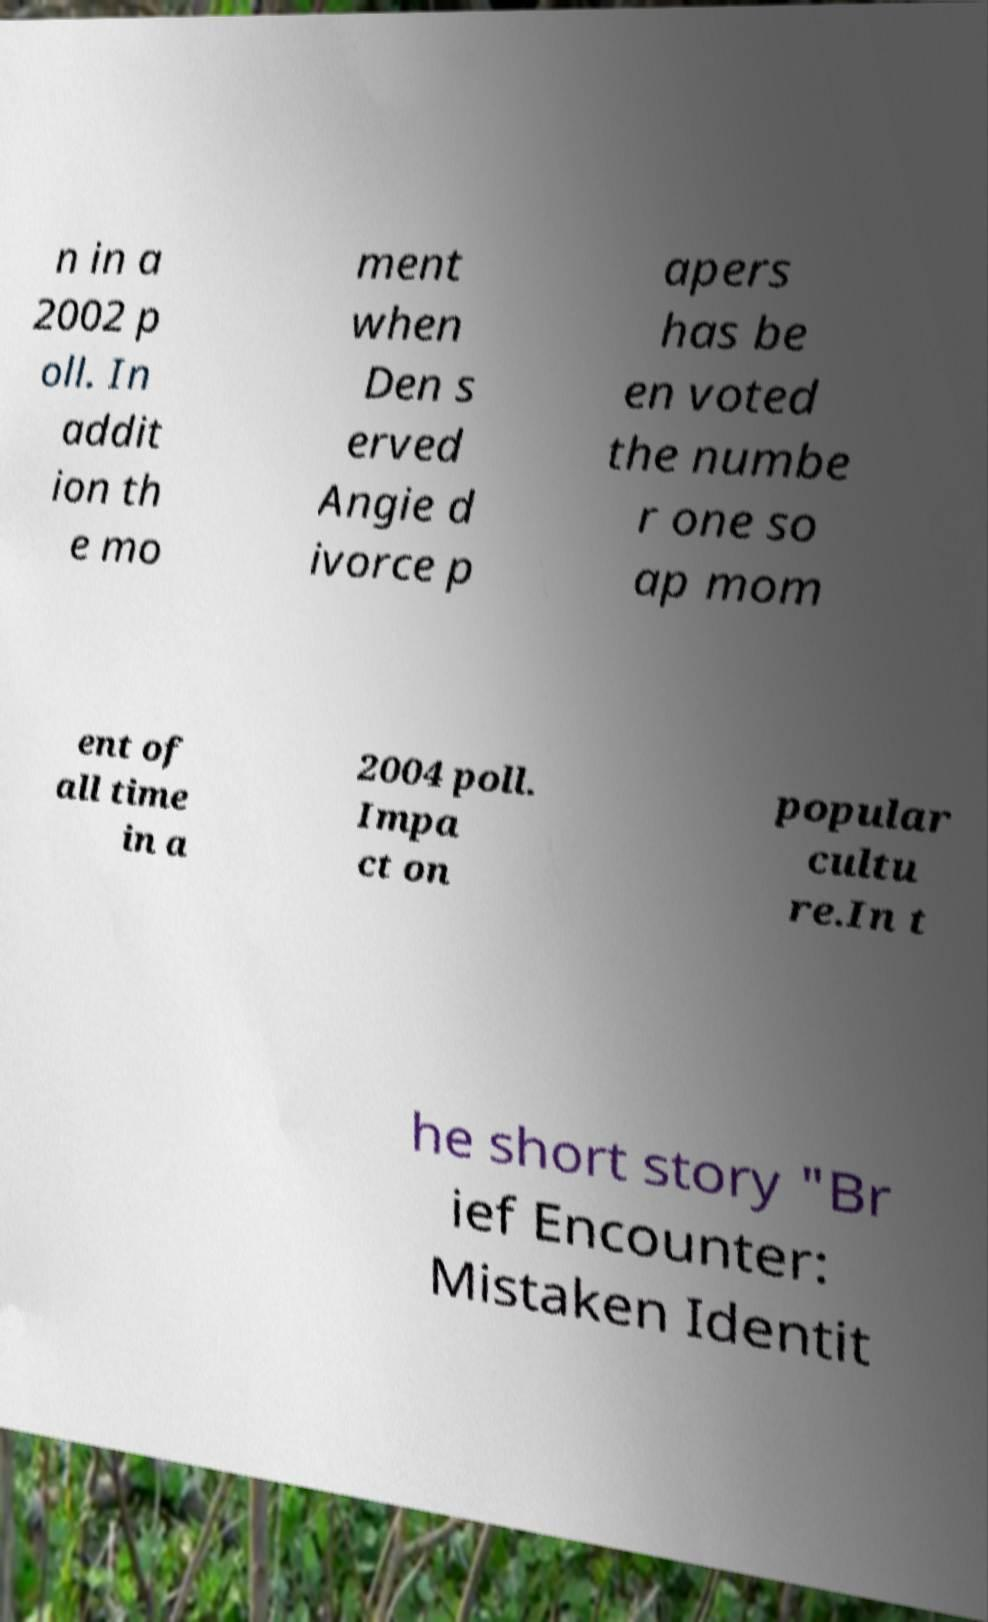What messages or text are displayed in this image? I need them in a readable, typed format. n in a 2002 p oll. In addit ion th e mo ment when Den s erved Angie d ivorce p apers has be en voted the numbe r one so ap mom ent of all time in a 2004 poll. Impa ct on popular cultu re.In t he short story "Br ief Encounter: Mistaken Identit 